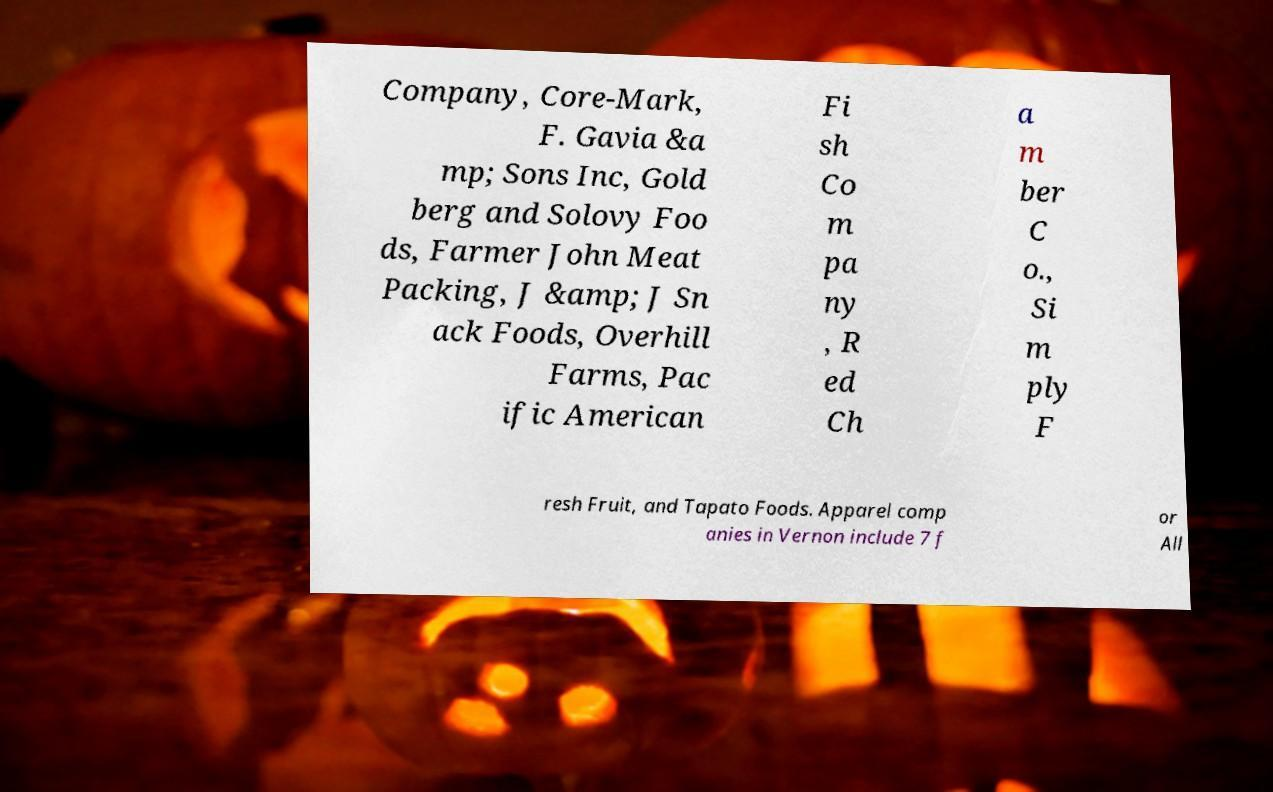There's text embedded in this image that I need extracted. Can you transcribe it verbatim? Company, Core-Mark, F. Gavia &a mp; Sons Inc, Gold berg and Solovy Foo ds, Farmer John Meat Packing, J &amp; J Sn ack Foods, Overhill Farms, Pac ific American Fi sh Co m pa ny , R ed Ch a m ber C o., Si m ply F resh Fruit, and Tapato Foods. Apparel comp anies in Vernon include 7 f or All 